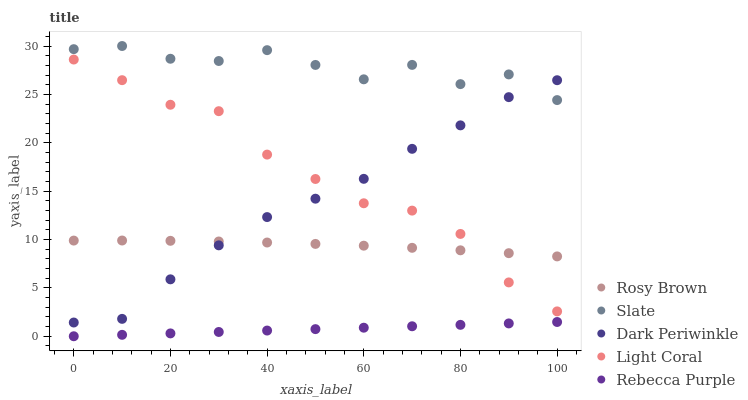Does Rebecca Purple have the minimum area under the curve?
Answer yes or no. Yes. Does Slate have the maximum area under the curve?
Answer yes or no. Yes. Does Rosy Brown have the minimum area under the curve?
Answer yes or no. No. Does Rosy Brown have the maximum area under the curve?
Answer yes or no. No. Is Rebecca Purple the smoothest?
Answer yes or no. Yes. Is Slate the roughest?
Answer yes or no. Yes. Is Rosy Brown the smoothest?
Answer yes or no. No. Is Rosy Brown the roughest?
Answer yes or no. No. Does Rebecca Purple have the lowest value?
Answer yes or no. Yes. Does Rosy Brown have the lowest value?
Answer yes or no. No. Does Slate have the highest value?
Answer yes or no. Yes. Does Rosy Brown have the highest value?
Answer yes or no. No. Is Rebecca Purple less than Slate?
Answer yes or no. Yes. Is Rosy Brown greater than Rebecca Purple?
Answer yes or no. Yes. Does Slate intersect Dark Periwinkle?
Answer yes or no. Yes. Is Slate less than Dark Periwinkle?
Answer yes or no. No. Is Slate greater than Dark Periwinkle?
Answer yes or no. No. Does Rebecca Purple intersect Slate?
Answer yes or no. No. 